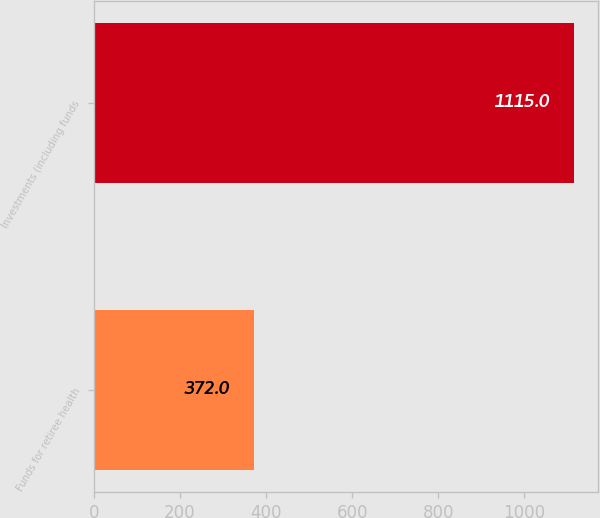Convert chart. <chart><loc_0><loc_0><loc_500><loc_500><bar_chart><fcel>Funds for retiree health<fcel>Investments (including funds<nl><fcel>372<fcel>1115<nl></chart> 